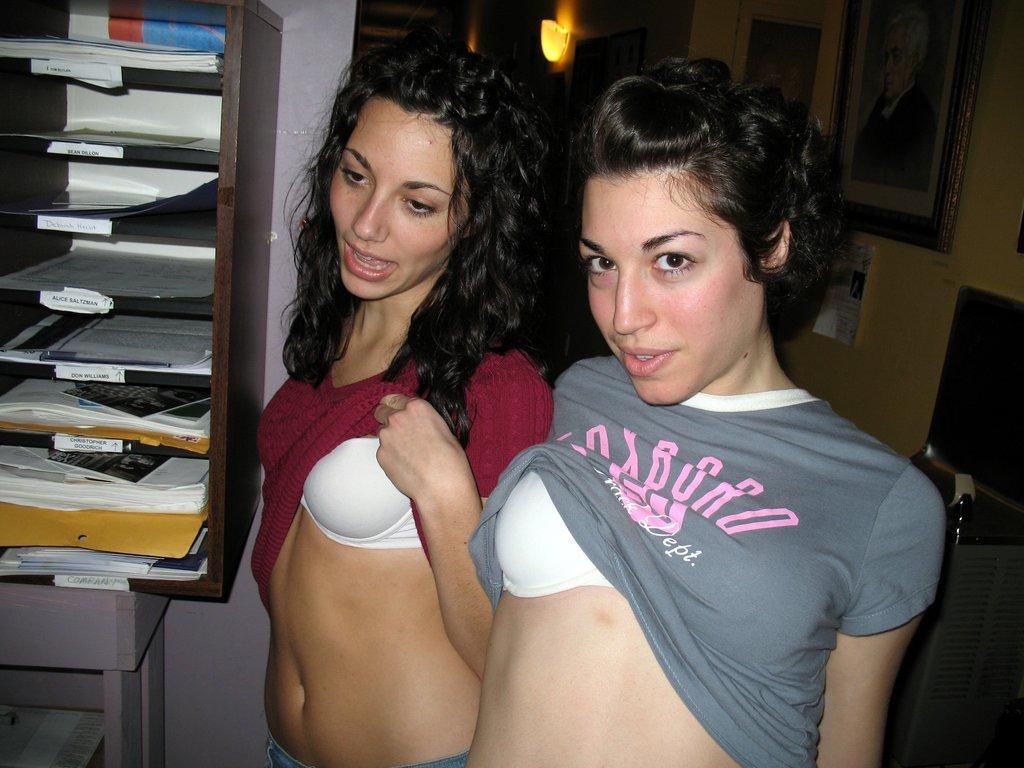<image>
Render a clear and concise summary of the photo. A girl wearing a gray Foxboro shirt and her friend flash their bras. 